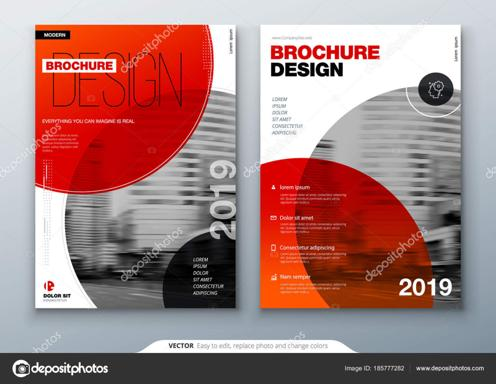What are the main colors used in the brochure template? The brochure template primarily utilizes a bold red and stark black, creating a visually striking contrast that makes the text and design elements pop against the white background. This color scheme is ideal for capturing attention and conveying a sense of professionalism and dynamism. 